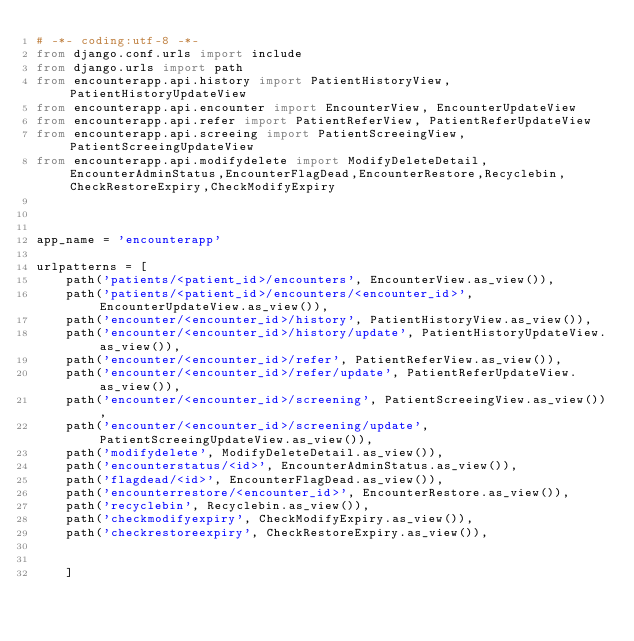<code> <loc_0><loc_0><loc_500><loc_500><_Python_># -*- coding:utf-8 -*-
from django.conf.urls import include
from django.urls import path
from encounterapp.api.history import PatientHistoryView, PatientHistoryUpdateView
from encounterapp.api.encounter import EncounterView, EncounterUpdateView
from encounterapp.api.refer import PatientReferView, PatientReferUpdateView
from encounterapp.api.screeing import PatientScreeingView, PatientScreeingUpdateView
from encounterapp.api.modifydelete import ModifyDeleteDetail,EncounterAdminStatus,EncounterFlagDead,EncounterRestore,Recyclebin,CheckRestoreExpiry,CheckModifyExpiry



app_name = 'encounterapp'

urlpatterns = [
	path('patients/<patient_id>/encounters', EncounterView.as_view()),
	path('patients/<patient_id>/encounters/<encounter_id>', EncounterUpdateView.as_view()),
	path('encounter/<encounter_id>/history', PatientHistoryView.as_view()),
	path('encounter/<encounter_id>/history/update', PatientHistoryUpdateView.as_view()),
	path('encounter/<encounter_id>/refer', PatientReferView.as_view()),
	path('encounter/<encounter_id>/refer/update', PatientReferUpdateView.as_view()),
	path('encounter/<encounter_id>/screening', PatientScreeingView.as_view()),
	path('encounter/<encounter_id>/screening/update', PatientScreeingUpdateView.as_view()),
	path('modifydelete', ModifyDeleteDetail.as_view()),
	path('encounterstatus/<id>', EncounterAdminStatus.as_view()),
	path('flagdead/<id>', EncounterFlagDead.as_view()),
	path('encounterrestore/<encounter_id>', EncounterRestore.as_view()),
	path('recyclebin', Recyclebin.as_view()),
	path('checkmodifyexpiry', CheckModifyExpiry.as_view()),
	path('checkrestoreexpiry', CheckRestoreExpiry.as_view()),
	

    ]
</code> 